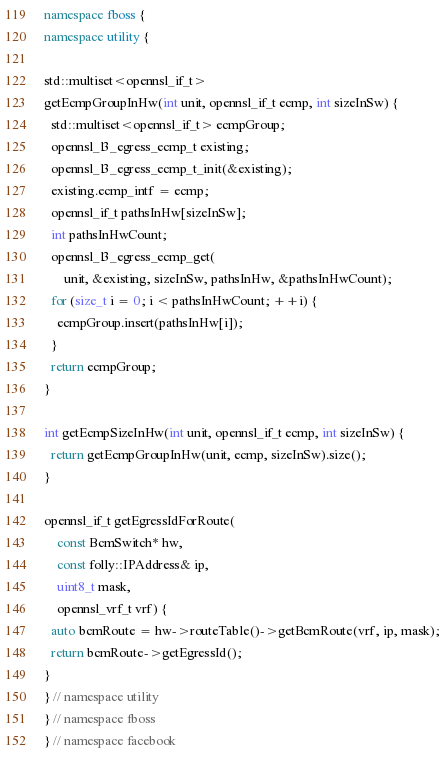Convert code to text. <code><loc_0><loc_0><loc_500><loc_500><_C++_>namespace fboss {
namespace utility {

std::multiset<opennsl_if_t>
getEcmpGroupInHw(int unit, opennsl_if_t ecmp, int sizeInSw) {
  std::multiset<opennsl_if_t> ecmpGroup;
  opennsl_l3_egress_ecmp_t existing;
  opennsl_l3_egress_ecmp_t_init(&existing);
  existing.ecmp_intf = ecmp;
  opennsl_if_t pathsInHw[sizeInSw];
  int pathsInHwCount;
  opennsl_l3_egress_ecmp_get(
      unit, &existing, sizeInSw, pathsInHw, &pathsInHwCount);
  for (size_t i = 0; i < pathsInHwCount; ++i) {
    ecmpGroup.insert(pathsInHw[i]);
  }
  return ecmpGroup;
}

int getEcmpSizeInHw(int unit, opennsl_if_t ecmp, int sizeInSw) {
  return getEcmpGroupInHw(unit, ecmp, sizeInSw).size();
}

opennsl_if_t getEgressIdForRoute(
    const BcmSwitch* hw,
    const folly::IPAddress& ip,
    uint8_t mask,
    opennsl_vrf_t vrf) {
  auto bcmRoute = hw->routeTable()->getBcmRoute(vrf, ip, mask);
  return bcmRoute->getEgressId();
}
} // namespace utility
} // namespace fboss
} // namespace facebook
</code> 